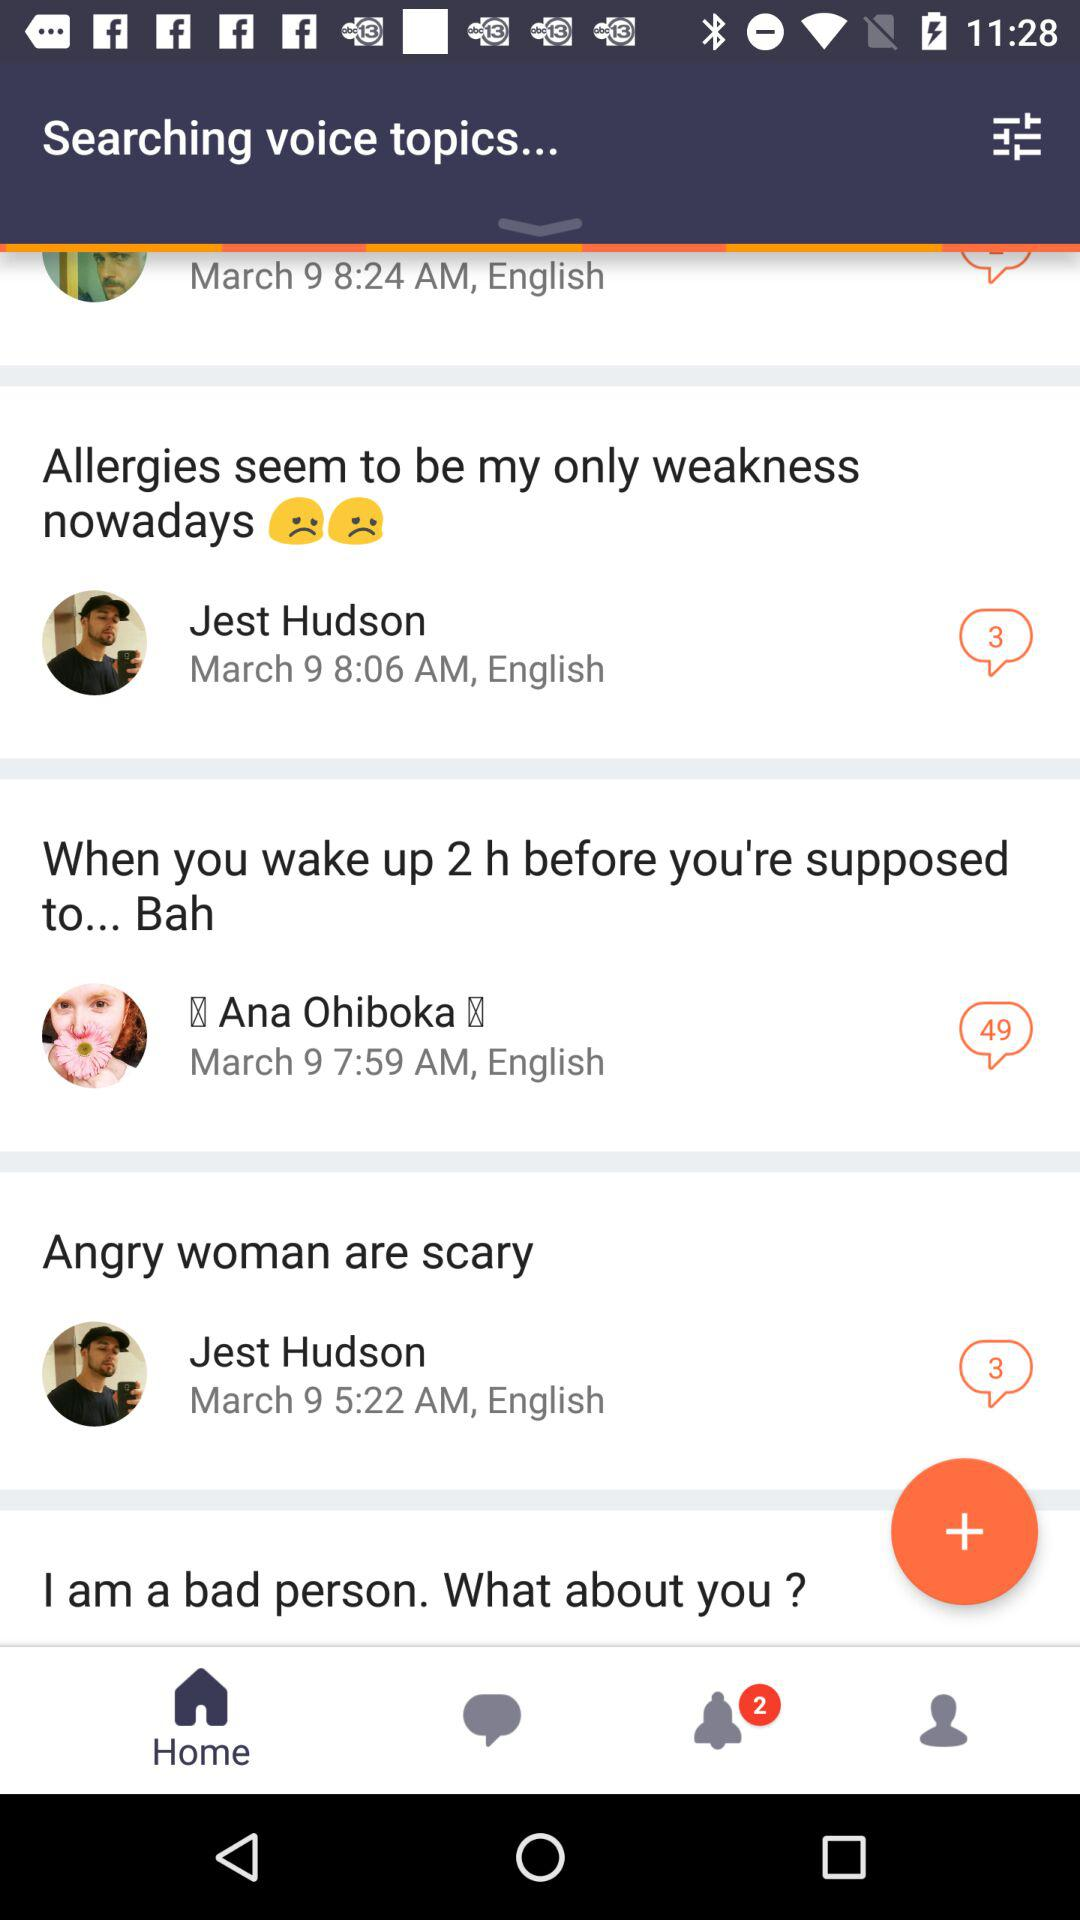What comment was posted at 5:22 a.m. on March 9? The comment posted was "Angry woman are scary". 